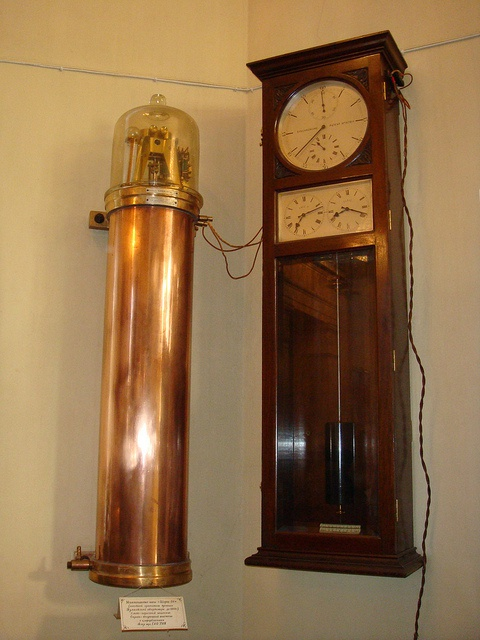Describe the objects in this image and their specific colors. I can see clock in tan and olive tones, clock in tan and olive tones, and clock in tan, olive, and orange tones in this image. 